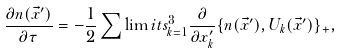Convert formula to latex. <formula><loc_0><loc_0><loc_500><loc_500>\frac { \partial n ( \vec { x } ^ { \prime } ) } { \partial \tau } = - \frac { 1 } { 2 } \sum \lim i t s _ { k = 1 } ^ { 3 } \frac { \partial } { \partial x _ { k } ^ { \prime } } \{ { n ( \vec { x } ^ { \prime } ) , U _ { k } ( \vec { x } ^ { \prime } ) } \} _ { + } ,</formula> 